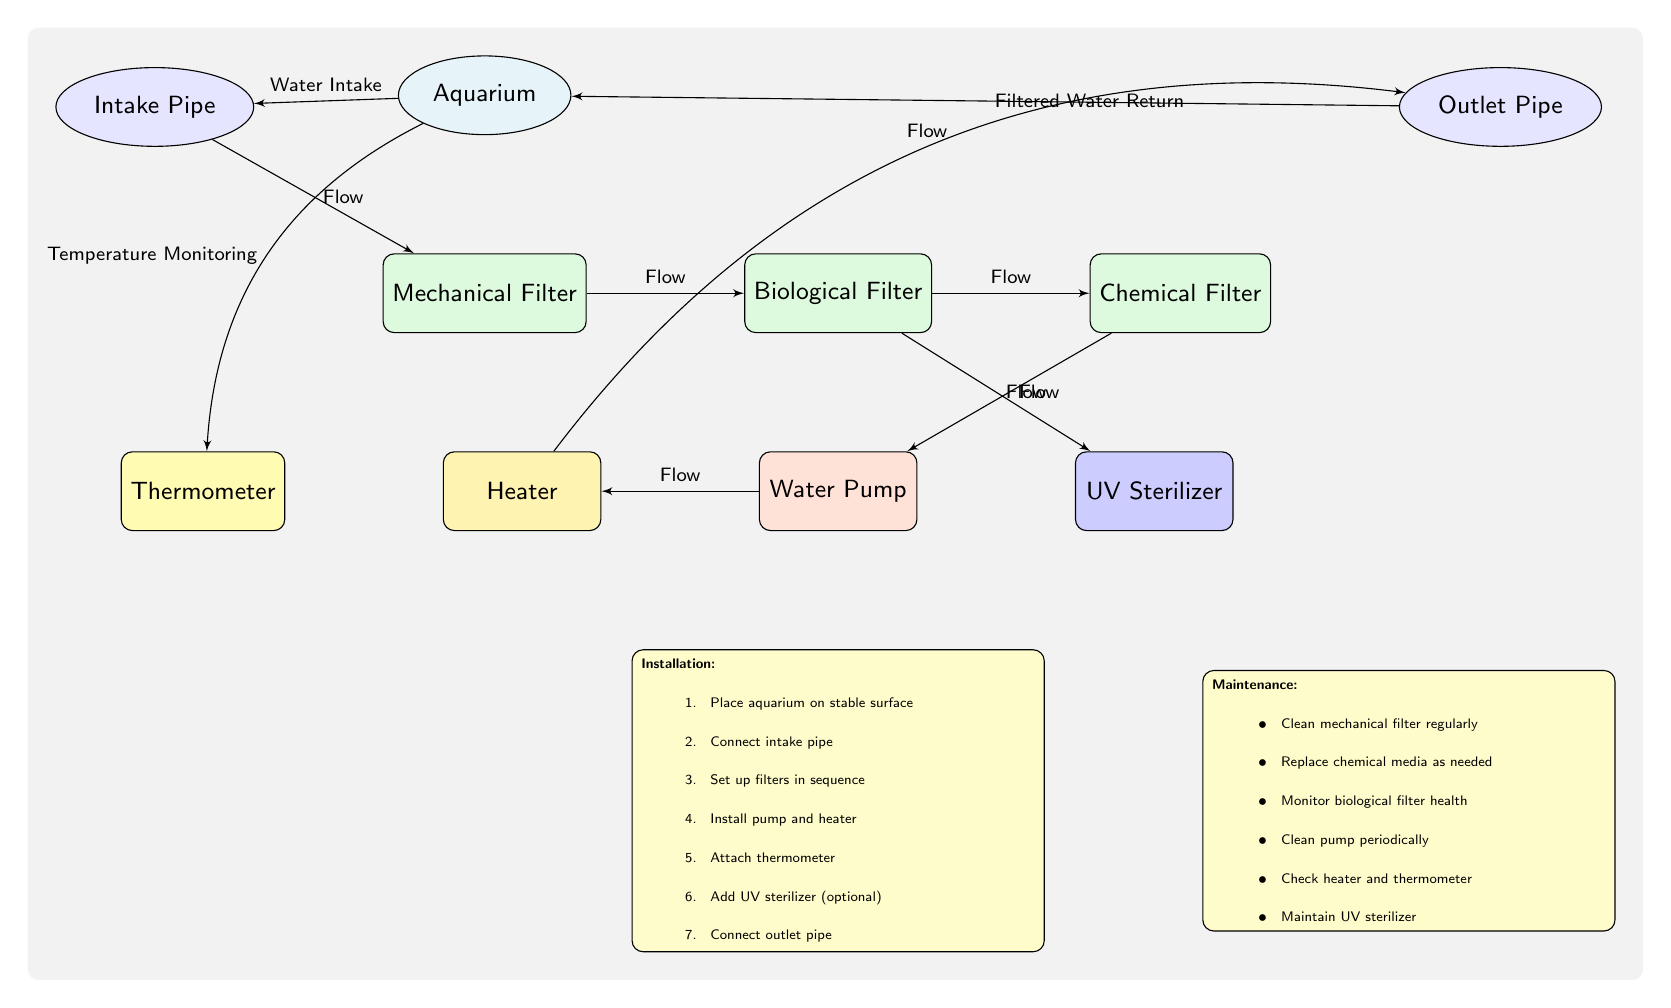What is the color of the biological filter? The biological filter is depicted in the diagram with a fill color of filter green, which is represented by the RGB values defined as (144,238,144).
Answer: filter green How many types of filters are represented in the diagram? The diagram features three types of filters: mechanical, biological, and chemical. Counting these nodes gives a total of three filters.
Answer: three Which component is connected directly to the outlet pipe? The outlet pipe connects directly to the aquarium, as shown by the edge leading from the outlet to the aquarium node, indicating the return path of filtered water.
Answer: aquarium What is the last step in the installation instructions? The last step listed in the installation instructions is to connect the outlet pipe, completing the setup of the water filtration and circulation system.
Answer: connect outlet pipe How often should the mechanical filter be cleaned according to the maintenance instructions? The maintenance instructions specify that the mechanical filter should be cleaned regularly, indicating a need for routine maintenance but not specifying a time frame.
Answer: regularly What is the flow direction from the mechanical filter to the biological filter? The flow direction from the mechanical filter to the biological filter is indicated as a direct edge in the diagram, labeled with the term 'Flow', highlighting the connection.
Answer: Flow What component comes after the chemical filter in the system? The water pump is connected to the chemical filter and follows it in the system, signified by the directional edge labeled 'Flow' leading from the chemical filter to the pump.
Answer: water pump Which additional component can be added optionally to the system? The UV sterilizer is noted as an optional addition to the filtration and circulation setup, as indicated in the diagram beside the biological filter node.
Answer: UV sterilizer How should the thermometer be positioned relative to the heater? The thermometer is positioned to the left of the heater in the diagram, illustrating its placement in relation to the heater node in the schematic layout.
Answer: left 